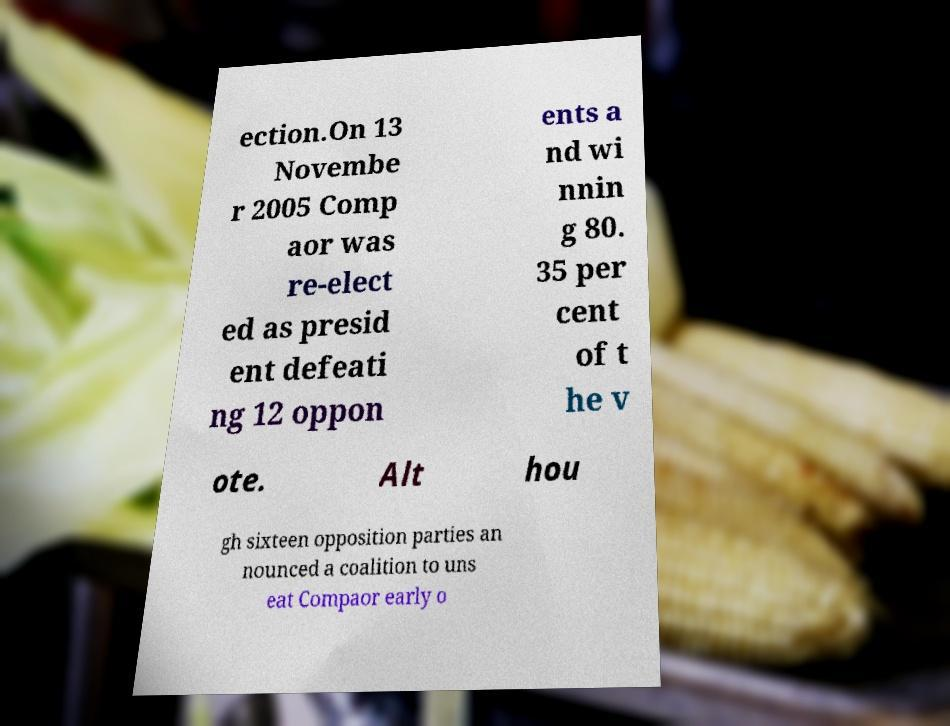Can you accurately transcribe the text from the provided image for me? ection.On 13 Novembe r 2005 Comp aor was re-elect ed as presid ent defeati ng 12 oppon ents a nd wi nnin g 80. 35 per cent of t he v ote. Alt hou gh sixteen opposition parties an nounced a coalition to uns eat Compaor early o 